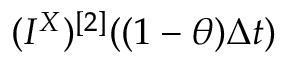Convert formula to latex. <formula><loc_0><loc_0><loc_500><loc_500>( I ^ { X } ) ^ { [ 2 ] } ( ( 1 - \theta ) \Delta t )</formula> 